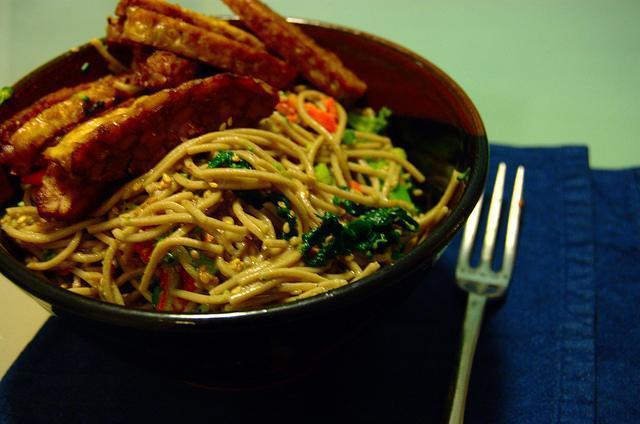How many people are on the slope?
Give a very brief answer. 0. 